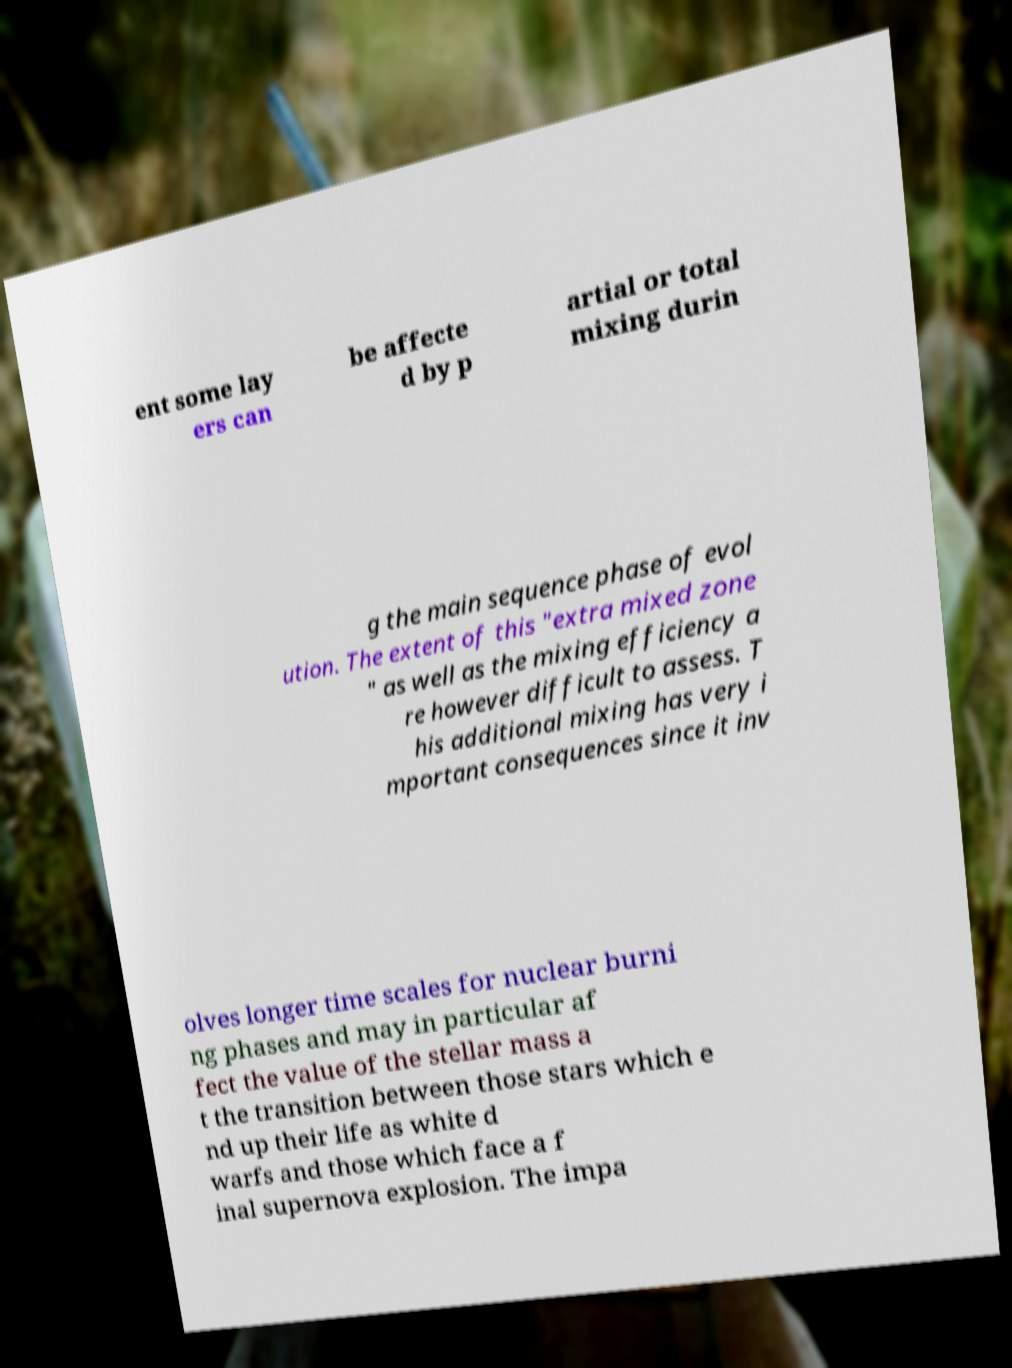Could you assist in decoding the text presented in this image and type it out clearly? ent some lay ers can be affecte d by p artial or total mixing durin g the main sequence phase of evol ution. The extent of this "extra mixed zone " as well as the mixing efficiency a re however difficult to assess. T his additional mixing has very i mportant consequences since it inv olves longer time scales for nuclear burni ng phases and may in particular af fect the value of the stellar mass a t the transition between those stars which e nd up their life as white d warfs and those which face a f inal supernova explosion. The impa 